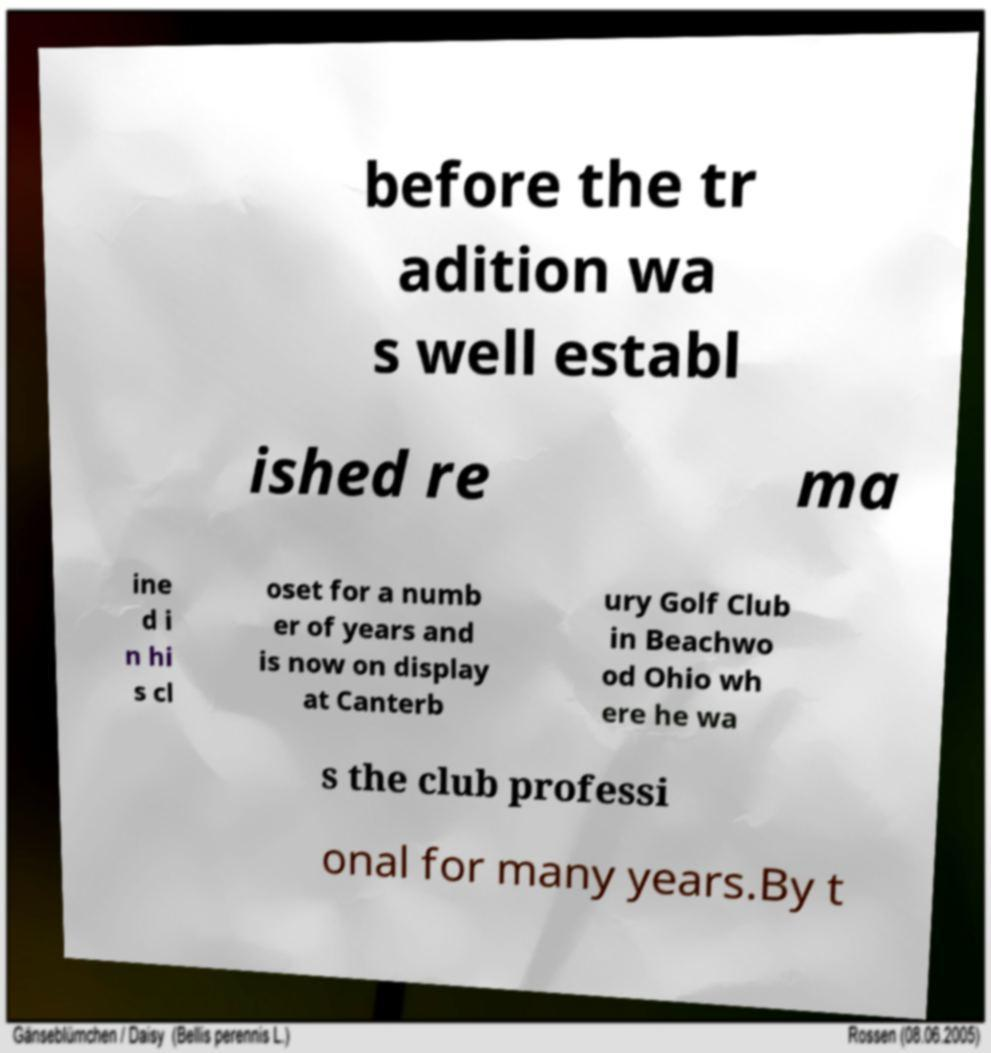Can you accurately transcribe the text from the provided image for me? before the tr adition wa s well establ ished re ma ine d i n hi s cl oset for a numb er of years and is now on display at Canterb ury Golf Club in Beachwo od Ohio wh ere he wa s the club professi onal for many years.By t 